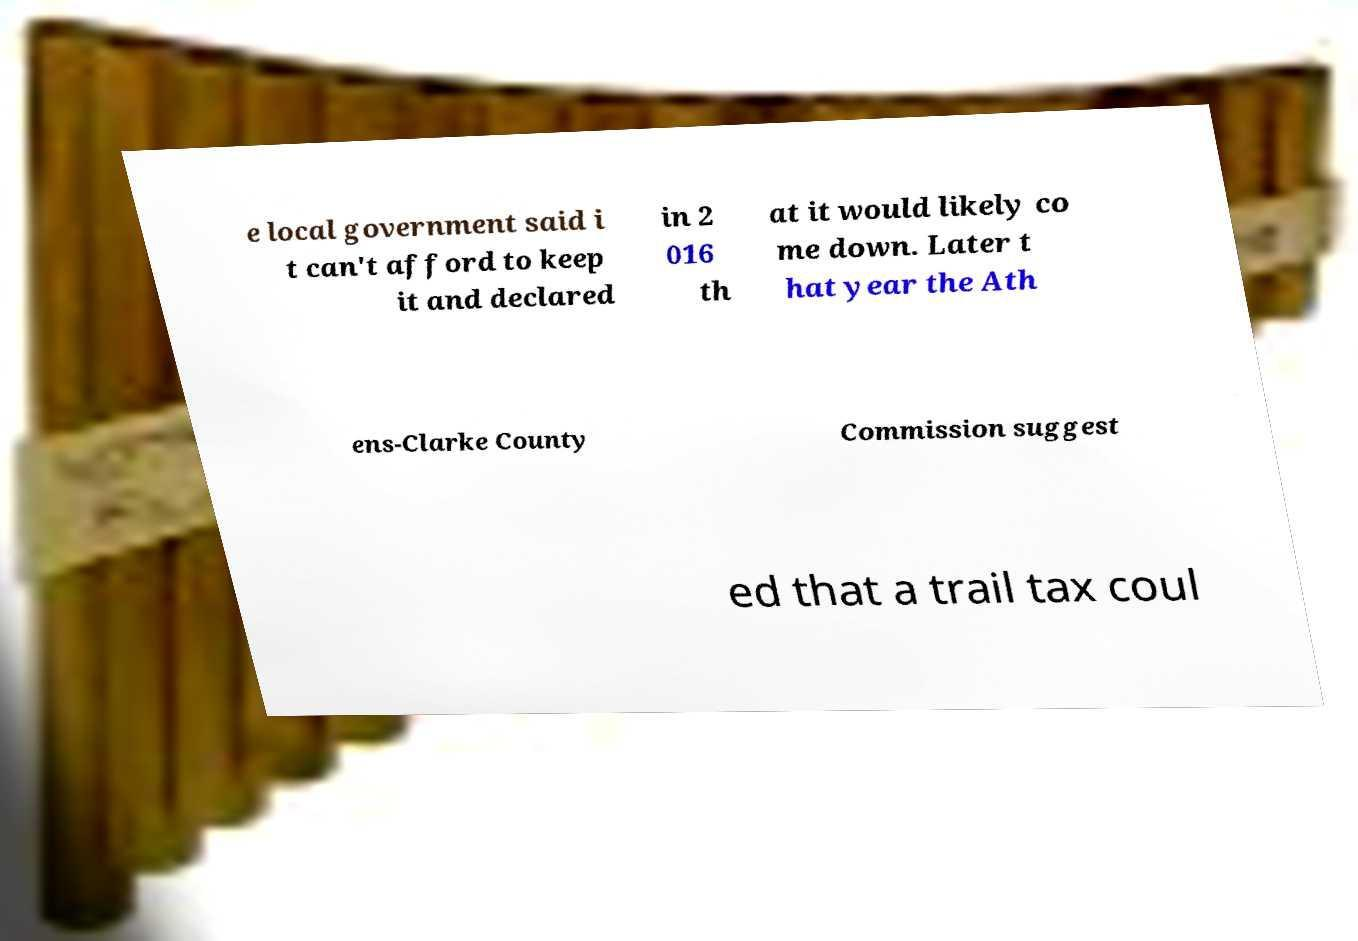Please read and relay the text visible in this image. What does it say? e local government said i t can't afford to keep it and declared in 2 016 th at it would likely co me down. Later t hat year the Ath ens-Clarke County Commission suggest ed that a trail tax coul 